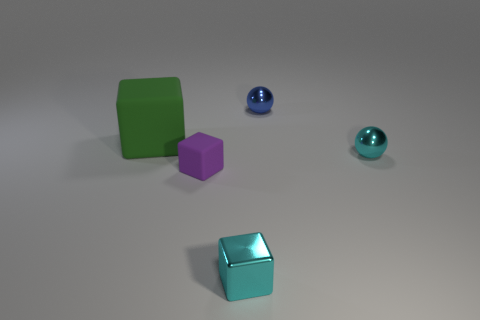Is the number of cyan things greater than the number of cyan matte things?
Offer a very short reply. Yes. Are there any large blue matte things?
Ensure brevity in your answer.  No. The small metal thing that is in front of the metallic sphere that is in front of the green matte cube is what shape?
Give a very brief answer. Cube. What number of objects are tiny green rubber spheres or metal things in front of the tiny rubber object?
Provide a short and direct response. 1. There is a cube behind the tiny cyan thing behind the tiny cube that is in front of the purple matte object; what is its color?
Your answer should be very brief. Green. What material is the cyan object that is the same shape as the green object?
Offer a terse response. Metal. The small metal block is what color?
Keep it short and to the point. Cyan. How many metal objects are red blocks or purple things?
Offer a very short reply. 0. Is there a cyan thing in front of the tiny blue shiny sphere left of the small object right of the blue sphere?
Your response must be concise. Yes. The purple cube that is made of the same material as the big thing is what size?
Make the answer very short. Small. 